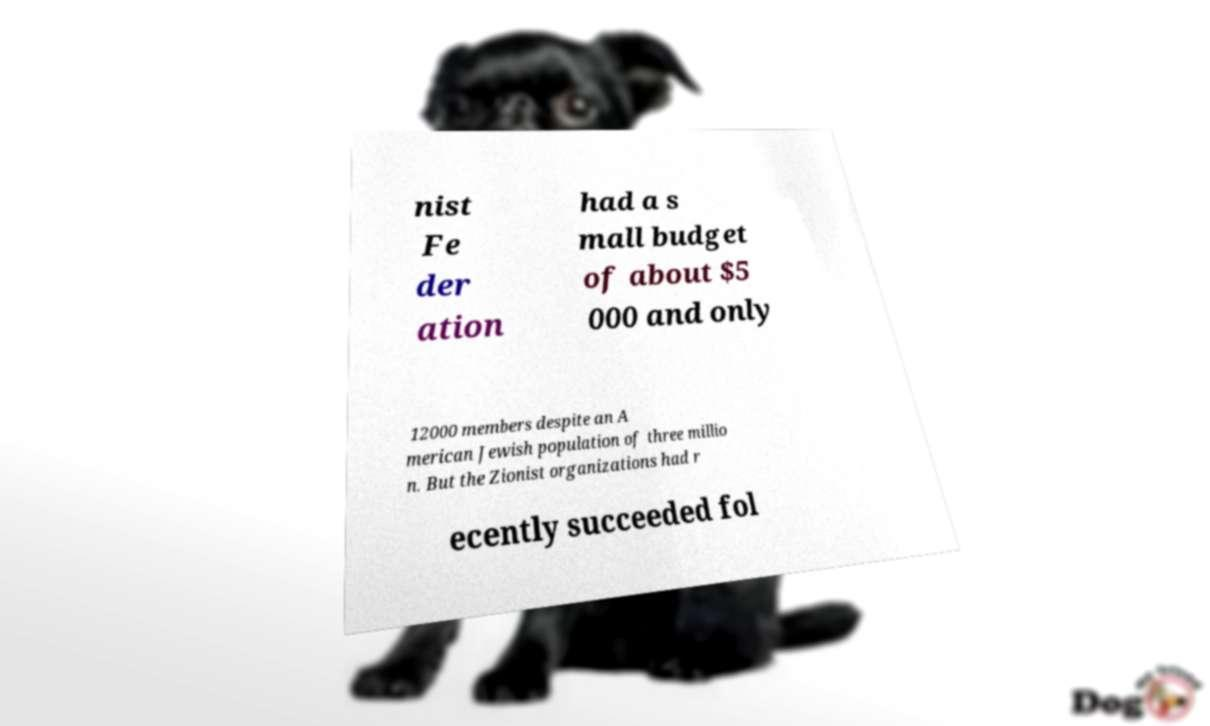I need the written content from this picture converted into text. Can you do that? nist Fe der ation had a s mall budget of about $5 000 and only 12000 members despite an A merican Jewish population of three millio n. But the Zionist organizations had r ecently succeeded fol 